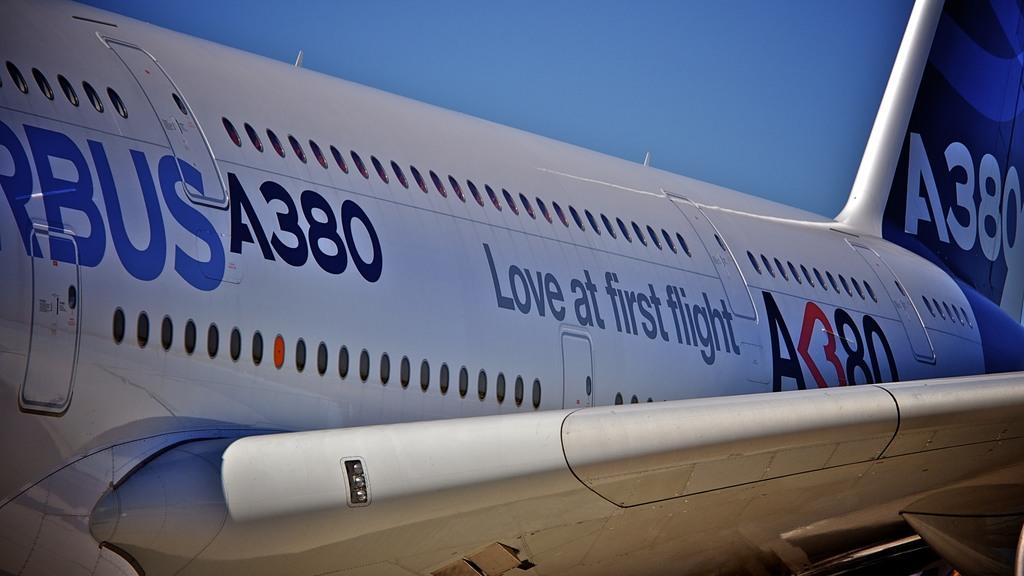What is the slogan on the plane?
Make the answer very short. Love at first flight. 